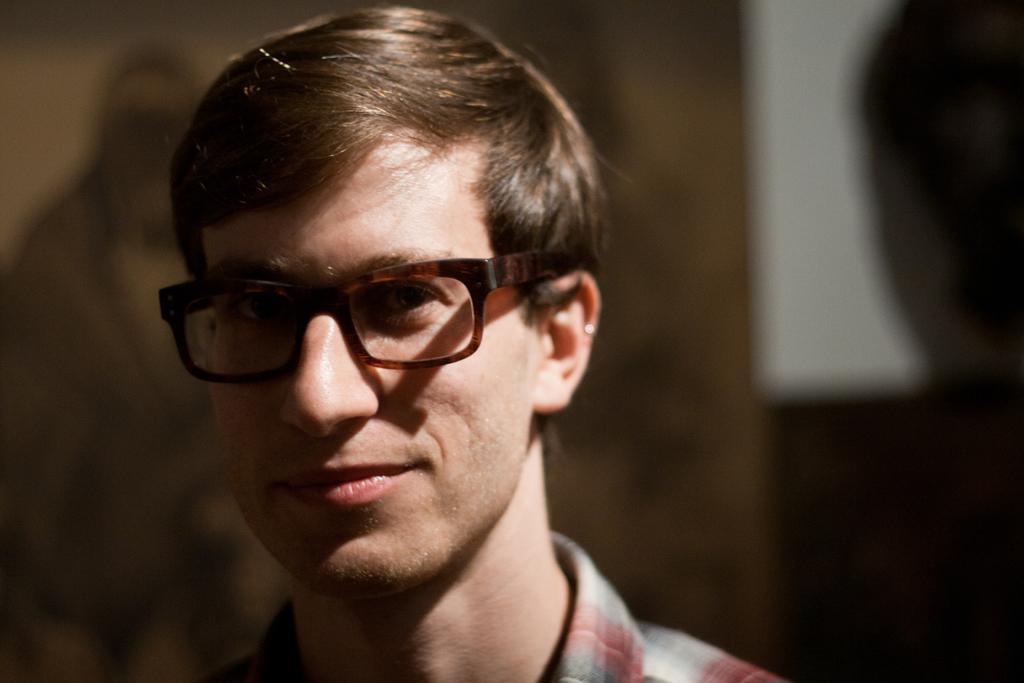Please provide a concise description of this image. In this image I can see a person wearing brown color spec. Background is in brown,black and white color. 